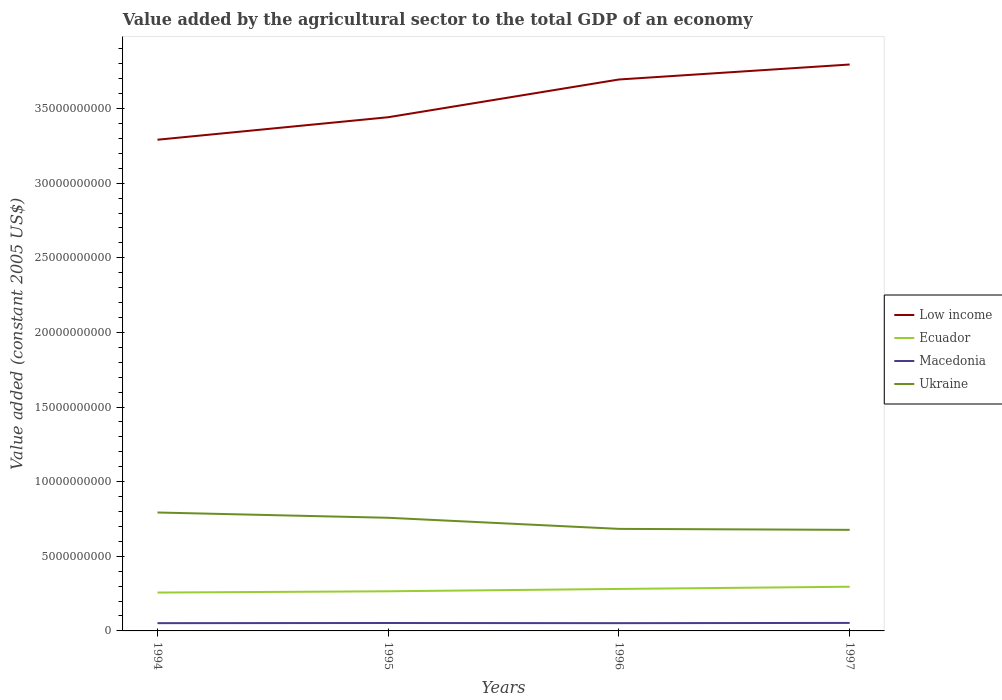Does the line corresponding to Ukraine intersect with the line corresponding to Low income?
Keep it short and to the point. No. Across all years, what is the maximum value added by the agricultural sector in Low income?
Ensure brevity in your answer.  3.29e+1. What is the total value added by the agricultural sector in Low income in the graph?
Ensure brevity in your answer.  -1.00e+09. What is the difference between the highest and the second highest value added by the agricultural sector in Low income?
Your answer should be very brief. 5.04e+09. Is the value added by the agricultural sector in Low income strictly greater than the value added by the agricultural sector in Macedonia over the years?
Offer a very short reply. No. How many lines are there?
Provide a short and direct response. 4. How many years are there in the graph?
Provide a short and direct response. 4. What is the title of the graph?
Your response must be concise. Value added by the agricultural sector to the total GDP of an economy. Does "Mongolia" appear as one of the legend labels in the graph?
Ensure brevity in your answer.  No. What is the label or title of the Y-axis?
Provide a short and direct response. Value added (constant 2005 US$). What is the Value added (constant 2005 US$) of Low income in 1994?
Your answer should be compact. 3.29e+1. What is the Value added (constant 2005 US$) of Ecuador in 1994?
Your response must be concise. 2.57e+09. What is the Value added (constant 2005 US$) of Macedonia in 1994?
Give a very brief answer. 5.20e+08. What is the Value added (constant 2005 US$) of Ukraine in 1994?
Ensure brevity in your answer.  7.94e+09. What is the Value added (constant 2005 US$) in Low income in 1995?
Provide a succinct answer. 3.44e+1. What is the Value added (constant 2005 US$) of Ecuador in 1995?
Offer a very short reply. 2.66e+09. What is the Value added (constant 2005 US$) in Macedonia in 1995?
Your response must be concise. 5.31e+08. What is the Value added (constant 2005 US$) in Ukraine in 1995?
Provide a succinct answer. 7.58e+09. What is the Value added (constant 2005 US$) of Low income in 1996?
Provide a short and direct response. 3.70e+1. What is the Value added (constant 2005 US$) of Ecuador in 1996?
Your answer should be compact. 2.81e+09. What is the Value added (constant 2005 US$) of Macedonia in 1996?
Provide a succinct answer. 5.20e+08. What is the Value added (constant 2005 US$) in Ukraine in 1996?
Keep it short and to the point. 6.84e+09. What is the Value added (constant 2005 US$) in Low income in 1997?
Your answer should be very brief. 3.80e+1. What is the Value added (constant 2005 US$) in Ecuador in 1997?
Make the answer very short. 2.96e+09. What is the Value added (constant 2005 US$) of Macedonia in 1997?
Your answer should be compact. 5.36e+08. What is the Value added (constant 2005 US$) of Ukraine in 1997?
Make the answer very short. 6.77e+09. Across all years, what is the maximum Value added (constant 2005 US$) in Low income?
Offer a terse response. 3.80e+1. Across all years, what is the maximum Value added (constant 2005 US$) of Ecuador?
Your answer should be compact. 2.96e+09. Across all years, what is the maximum Value added (constant 2005 US$) of Macedonia?
Ensure brevity in your answer.  5.36e+08. Across all years, what is the maximum Value added (constant 2005 US$) of Ukraine?
Your answer should be very brief. 7.94e+09. Across all years, what is the minimum Value added (constant 2005 US$) in Low income?
Your response must be concise. 3.29e+1. Across all years, what is the minimum Value added (constant 2005 US$) of Ecuador?
Provide a succinct answer. 2.57e+09. Across all years, what is the minimum Value added (constant 2005 US$) of Macedonia?
Your response must be concise. 5.20e+08. Across all years, what is the minimum Value added (constant 2005 US$) of Ukraine?
Offer a terse response. 6.77e+09. What is the total Value added (constant 2005 US$) in Low income in the graph?
Your answer should be compact. 1.42e+11. What is the total Value added (constant 2005 US$) of Ecuador in the graph?
Your answer should be very brief. 1.10e+1. What is the total Value added (constant 2005 US$) in Macedonia in the graph?
Ensure brevity in your answer.  2.11e+09. What is the total Value added (constant 2005 US$) of Ukraine in the graph?
Ensure brevity in your answer.  2.91e+1. What is the difference between the Value added (constant 2005 US$) of Low income in 1994 and that in 1995?
Make the answer very short. -1.51e+09. What is the difference between the Value added (constant 2005 US$) of Ecuador in 1994 and that in 1995?
Ensure brevity in your answer.  -8.60e+07. What is the difference between the Value added (constant 2005 US$) in Macedonia in 1994 and that in 1995?
Ensure brevity in your answer.  -1.08e+07. What is the difference between the Value added (constant 2005 US$) in Ukraine in 1994 and that in 1995?
Your response must be concise. 3.53e+08. What is the difference between the Value added (constant 2005 US$) of Low income in 1994 and that in 1996?
Provide a succinct answer. -4.04e+09. What is the difference between the Value added (constant 2005 US$) of Ecuador in 1994 and that in 1996?
Keep it short and to the point. -2.43e+08. What is the difference between the Value added (constant 2005 US$) in Macedonia in 1994 and that in 1996?
Give a very brief answer. 8.42e+04. What is the difference between the Value added (constant 2005 US$) in Ukraine in 1994 and that in 1996?
Offer a very short reply. 1.10e+09. What is the difference between the Value added (constant 2005 US$) of Low income in 1994 and that in 1997?
Your answer should be very brief. -5.04e+09. What is the difference between the Value added (constant 2005 US$) in Ecuador in 1994 and that in 1997?
Your answer should be compact. -3.90e+08. What is the difference between the Value added (constant 2005 US$) of Macedonia in 1994 and that in 1997?
Keep it short and to the point. -1.57e+07. What is the difference between the Value added (constant 2005 US$) of Ukraine in 1994 and that in 1997?
Offer a very short reply. 1.16e+09. What is the difference between the Value added (constant 2005 US$) in Low income in 1995 and that in 1996?
Keep it short and to the point. -2.53e+09. What is the difference between the Value added (constant 2005 US$) of Ecuador in 1995 and that in 1996?
Provide a short and direct response. -1.57e+08. What is the difference between the Value added (constant 2005 US$) of Macedonia in 1995 and that in 1996?
Offer a very short reply. 1.09e+07. What is the difference between the Value added (constant 2005 US$) of Ukraine in 1995 and that in 1996?
Ensure brevity in your answer.  7.44e+08. What is the difference between the Value added (constant 2005 US$) in Low income in 1995 and that in 1997?
Offer a terse response. -3.53e+09. What is the difference between the Value added (constant 2005 US$) of Ecuador in 1995 and that in 1997?
Keep it short and to the point. -3.04e+08. What is the difference between the Value added (constant 2005 US$) in Macedonia in 1995 and that in 1997?
Your answer should be very brief. -4.85e+06. What is the difference between the Value added (constant 2005 US$) in Ukraine in 1995 and that in 1997?
Your answer should be compact. 8.09e+08. What is the difference between the Value added (constant 2005 US$) of Low income in 1996 and that in 1997?
Your answer should be very brief. -1.00e+09. What is the difference between the Value added (constant 2005 US$) of Ecuador in 1996 and that in 1997?
Offer a very short reply. -1.47e+08. What is the difference between the Value added (constant 2005 US$) of Macedonia in 1996 and that in 1997?
Make the answer very short. -1.57e+07. What is the difference between the Value added (constant 2005 US$) in Ukraine in 1996 and that in 1997?
Offer a very short reply. 6.52e+07. What is the difference between the Value added (constant 2005 US$) of Low income in 1994 and the Value added (constant 2005 US$) of Ecuador in 1995?
Offer a terse response. 3.03e+1. What is the difference between the Value added (constant 2005 US$) of Low income in 1994 and the Value added (constant 2005 US$) of Macedonia in 1995?
Provide a succinct answer. 3.24e+1. What is the difference between the Value added (constant 2005 US$) in Low income in 1994 and the Value added (constant 2005 US$) in Ukraine in 1995?
Ensure brevity in your answer.  2.53e+1. What is the difference between the Value added (constant 2005 US$) in Ecuador in 1994 and the Value added (constant 2005 US$) in Macedonia in 1995?
Offer a terse response. 2.04e+09. What is the difference between the Value added (constant 2005 US$) of Ecuador in 1994 and the Value added (constant 2005 US$) of Ukraine in 1995?
Provide a succinct answer. -5.01e+09. What is the difference between the Value added (constant 2005 US$) in Macedonia in 1994 and the Value added (constant 2005 US$) in Ukraine in 1995?
Your response must be concise. -7.06e+09. What is the difference between the Value added (constant 2005 US$) in Low income in 1994 and the Value added (constant 2005 US$) in Ecuador in 1996?
Provide a short and direct response. 3.01e+1. What is the difference between the Value added (constant 2005 US$) of Low income in 1994 and the Value added (constant 2005 US$) of Macedonia in 1996?
Offer a very short reply. 3.24e+1. What is the difference between the Value added (constant 2005 US$) of Low income in 1994 and the Value added (constant 2005 US$) of Ukraine in 1996?
Offer a very short reply. 2.61e+1. What is the difference between the Value added (constant 2005 US$) in Ecuador in 1994 and the Value added (constant 2005 US$) in Macedonia in 1996?
Offer a terse response. 2.05e+09. What is the difference between the Value added (constant 2005 US$) in Ecuador in 1994 and the Value added (constant 2005 US$) in Ukraine in 1996?
Provide a succinct answer. -4.27e+09. What is the difference between the Value added (constant 2005 US$) of Macedonia in 1994 and the Value added (constant 2005 US$) of Ukraine in 1996?
Your answer should be compact. -6.32e+09. What is the difference between the Value added (constant 2005 US$) of Low income in 1994 and the Value added (constant 2005 US$) of Ecuador in 1997?
Offer a terse response. 3.00e+1. What is the difference between the Value added (constant 2005 US$) of Low income in 1994 and the Value added (constant 2005 US$) of Macedonia in 1997?
Offer a terse response. 3.24e+1. What is the difference between the Value added (constant 2005 US$) in Low income in 1994 and the Value added (constant 2005 US$) in Ukraine in 1997?
Make the answer very short. 2.61e+1. What is the difference between the Value added (constant 2005 US$) of Ecuador in 1994 and the Value added (constant 2005 US$) of Macedonia in 1997?
Offer a terse response. 2.03e+09. What is the difference between the Value added (constant 2005 US$) in Ecuador in 1994 and the Value added (constant 2005 US$) in Ukraine in 1997?
Your answer should be very brief. -4.20e+09. What is the difference between the Value added (constant 2005 US$) in Macedonia in 1994 and the Value added (constant 2005 US$) in Ukraine in 1997?
Provide a short and direct response. -6.25e+09. What is the difference between the Value added (constant 2005 US$) in Low income in 1995 and the Value added (constant 2005 US$) in Ecuador in 1996?
Provide a short and direct response. 3.16e+1. What is the difference between the Value added (constant 2005 US$) in Low income in 1995 and the Value added (constant 2005 US$) in Macedonia in 1996?
Ensure brevity in your answer.  3.39e+1. What is the difference between the Value added (constant 2005 US$) of Low income in 1995 and the Value added (constant 2005 US$) of Ukraine in 1996?
Keep it short and to the point. 2.76e+1. What is the difference between the Value added (constant 2005 US$) in Ecuador in 1995 and the Value added (constant 2005 US$) in Macedonia in 1996?
Your answer should be very brief. 2.14e+09. What is the difference between the Value added (constant 2005 US$) of Ecuador in 1995 and the Value added (constant 2005 US$) of Ukraine in 1996?
Keep it short and to the point. -4.18e+09. What is the difference between the Value added (constant 2005 US$) of Macedonia in 1995 and the Value added (constant 2005 US$) of Ukraine in 1996?
Your answer should be very brief. -6.31e+09. What is the difference between the Value added (constant 2005 US$) of Low income in 1995 and the Value added (constant 2005 US$) of Ecuador in 1997?
Give a very brief answer. 3.15e+1. What is the difference between the Value added (constant 2005 US$) in Low income in 1995 and the Value added (constant 2005 US$) in Macedonia in 1997?
Keep it short and to the point. 3.39e+1. What is the difference between the Value added (constant 2005 US$) of Low income in 1995 and the Value added (constant 2005 US$) of Ukraine in 1997?
Give a very brief answer. 2.76e+1. What is the difference between the Value added (constant 2005 US$) in Ecuador in 1995 and the Value added (constant 2005 US$) in Macedonia in 1997?
Offer a very short reply. 2.12e+09. What is the difference between the Value added (constant 2005 US$) of Ecuador in 1995 and the Value added (constant 2005 US$) of Ukraine in 1997?
Make the answer very short. -4.12e+09. What is the difference between the Value added (constant 2005 US$) of Macedonia in 1995 and the Value added (constant 2005 US$) of Ukraine in 1997?
Your response must be concise. -6.24e+09. What is the difference between the Value added (constant 2005 US$) in Low income in 1996 and the Value added (constant 2005 US$) in Ecuador in 1997?
Your response must be concise. 3.40e+1. What is the difference between the Value added (constant 2005 US$) of Low income in 1996 and the Value added (constant 2005 US$) of Macedonia in 1997?
Give a very brief answer. 3.64e+1. What is the difference between the Value added (constant 2005 US$) in Low income in 1996 and the Value added (constant 2005 US$) in Ukraine in 1997?
Your answer should be compact. 3.02e+1. What is the difference between the Value added (constant 2005 US$) of Ecuador in 1996 and the Value added (constant 2005 US$) of Macedonia in 1997?
Provide a succinct answer. 2.28e+09. What is the difference between the Value added (constant 2005 US$) in Ecuador in 1996 and the Value added (constant 2005 US$) in Ukraine in 1997?
Provide a short and direct response. -3.96e+09. What is the difference between the Value added (constant 2005 US$) in Macedonia in 1996 and the Value added (constant 2005 US$) in Ukraine in 1997?
Keep it short and to the point. -6.25e+09. What is the average Value added (constant 2005 US$) in Low income per year?
Give a very brief answer. 3.56e+1. What is the average Value added (constant 2005 US$) in Ecuador per year?
Your answer should be compact. 2.75e+09. What is the average Value added (constant 2005 US$) in Macedonia per year?
Your answer should be compact. 5.27e+08. What is the average Value added (constant 2005 US$) of Ukraine per year?
Provide a short and direct response. 7.28e+09. In the year 1994, what is the difference between the Value added (constant 2005 US$) in Low income and Value added (constant 2005 US$) in Ecuador?
Offer a very short reply. 3.03e+1. In the year 1994, what is the difference between the Value added (constant 2005 US$) of Low income and Value added (constant 2005 US$) of Macedonia?
Keep it short and to the point. 3.24e+1. In the year 1994, what is the difference between the Value added (constant 2005 US$) of Low income and Value added (constant 2005 US$) of Ukraine?
Provide a short and direct response. 2.50e+1. In the year 1994, what is the difference between the Value added (constant 2005 US$) in Ecuador and Value added (constant 2005 US$) in Macedonia?
Provide a short and direct response. 2.05e+09. In the year 1994, what is the difference between the Value added (constant 2005 US$) of Ecuador and Value added (constant 2005 US$) of Ukraine?
Ensure brevity in your answer.  -5.36e+09. In the year 1994, what is the difference between the Value added (constant 2005 US$) of Macedonia and Value added (constant 2005 US$) of Ukraine?
Offer a terse response. -7.42e+09. In the year 1995, what is the difference between the Value added (constant 2005 US$) of Low income and Value added (constant 2005 US$) of Ecuador?
Your response must be concise. 3.18e+1. In the year 1995, what is the difference between the Value added (constant 2005 US$) of Low income and Value added (constant 2005 US$) of Macedonia?
Offer a very short reply. 3.39e+1. In the year 1995, what is the difference between the Value added (constant 2005 US$) of Low income and Value added (constant 2005 US$) of Ukraine?
Your answer should be very brief. 2.68e+1. In the year 1995, what is the difference between the Value added (constant 2005 US$) in Ecuador and Value added (constant 2005 US$) in Macedonia?
Your answer should be compact. 2.13e+09. In the year 1995, what is the difference between the Value added (constant 2005 US$) of Ecuador and Value added (constant 2005 US$) of Ukraine?
Your response must be concise. -4.93e+09. In the year 1995, what is the difference between the Value added (constant 2005 US$) in Macedonia and Value added (constant 2005 US$) in Ukraine?
Provide a succinct answer. -7.05e+09. In the year 1996, what is the difference between the Value added (constant 2005 US$) of Low income and Value added (constant 2005 US$) of Ecuador?
Provide a succinct answer. 3.41e+1. In the year 1996, what is the difference between the Value added (constant 2005 US$) in Low income and Value added (constant 2005 US$) in Macedonia?
Ensure brevity in your answer.  3.64e+1. In the year 1996, what is the difference between the Value added (constant 2005 US$) of Low income and Value added (constant 2005 US$) of Ukraine?
Your answer should be very brief. 3.01e+1. In the year 1996, what is the difference between the Value added (constant 2005 US$) in Ecuador and Value added (constant 2005 US$) in Macedonia?
Your answer should be compact. 2.29e+09. In the year 1996, what is the difference between the Value added (constant 2005 US$) of Ecuador and Value added (constant 2005 US$) of Ukraine?
Your response must be concise. -4.02e+09. In the year 1996, what is the difference between the Value added (constant 2005 US$) in Macedonia and Value added (constant 2005 US$) in Ukraine?
Make the answer very short. -6.32e+09. In the year 1997, what is the difference between the Value added (constant 2005 US$) of Low income and Value added (constant 2005 US$) of Ecuador?
Offer a terse response. 3.50e+1. In the year 1997, what is the difference between the Value added (constant 2005 US$) of Low income and Value added (constant 2005 US$) of Macedonia?
Offer a terse response. 3.74e+1. In the year 1997, what is the difference between the Value added (constant 2005 US$) of Low income and Value added (constant 2005 US$) of Ukraine?
Provide a succinct answer. 3.12e+1. In the year 1997, what is the difference between the Value added (constant 2005 US$) in Ecuador and Value added (constant 2005 US$) in Macedonia?
Provide a short and direct response. 2.42e+09. In the year 1997, what is the difference between the Value added (constant 2005 US$) in Ecuador and Value added (constant 2005 US$) in Ukraine?
Provide a succinct answer. -3.81e+09. In the year 1997, what is the difference between the Value added (constant 2005 US$) in Macedonia and Value added (constant 2005 US$) in Ukraine?
Offer a very short reply. -6.24e+09. What is the ratio of the Value added (constant 2005 US$) in Low income in 1994 to that in 1995?
Offer a terse response. 0.96. What is the ratio of the Value added (constant 2005 US$) of Ecuador in 1994 to that in 1995?
Make the answer very short. 0.97. What is the ratio of the Value added (constant 2005 US$) of Macedonia in 1994 to that in 1995?
Your answer should be compact. 0.98. What is the ratio of the Value added (constant 2005 US$) of Ukraine in 1994 to that in 1995?
Ensure brevity in your answer.  1.05. What is the ratio of the Value added (constant 2005 US$) of Low income in 1994 to that in 1996?
Offer a very short reply. 0.89. What is the ratio of the Value added (constant 2005 US$) of Ecuador in 1994 to that in 1996?
Your response must be concise. 0.91. What is the ratio of the Value added (constant 2005 US$) in Macedonia in 1994 to that in 1996?
Ensure brevity in your answer.  1. What is the ratio of the Value added (constant 2005 US$) of Ukraine in 1994 to that in 1996?
Offer a terse response. 1.16. What is the ratio of the Value added (constant 2005 US$) of Low income in 1994 to that in 1997?
Offer a terse response. 0.87. What is the ratio of the Value added (constant 2005 US$) of Ecuador in 1994 to that in 1997?
Give a very brief answer. 0.87. What is the ratio of the Value added (constant 2005 US$) in Macedonia in 1994 to that in 1997?
Give a very brief answer. 0.97. What is the ratio of the Value added (constant 2005 US$) in Ukraine in 1994 to that in 1997?
Make the answer very short. 1.17. What is the ratio of the Value added (constant 2005 US$) in Low income in 1995 to that in 1996?
Keep it short and to the point. 0.93. What is the ratio of the Value added (constant 2005 US$) of Ecuador in 1995 to that in 1996?
Keep it short and to the point. 0.94. What is the ratio of the Value added (constant 2005 US$) in Macedonia in 1995 to that in 1996?
Offer a very short reply. 1.02. What is the ratio of the Value added (constant 2005 US$) of Ukraine in 1995 to that in 1996?
Ensure brevity in your answer.  1.11. What is the ratio of the Value added (constant 2005 US$) of Low income in 1995 to that in 1997?
Offer a terse response. 0.91. What is the ratio of the Value added (constant 2005 US$) in Ecuador in 1995 to that in 1997?
Make the answer very short. 0.9. What is the ratio of the Value added (constant 2005 US$) in Macedonia in 1995 to that in 1997?
Ensure brevity in your answer.  0.99. What is the ratio of the Value added (constant 2005 US$) in Ukraine in 1995 to that in 1997?
Offer a very short reply. 1.12. What is the ratio of the Value added (constant 2005 US$) in Low income in 1996 to that in 1997?
Your answer should be compact. 0.97. What is the ratio of the Value added (constant 2005 US$) in Ecuador in 1996 to that in 1997?
Your answer should be very brief. 0.95. What is the ratio of the Value added (constant 2005 US$) in Macedonia in 1996 to that in 1997?
Your answer should be very brief. 0.97. What is the ratio of the Value added (constant 2005 US$) in Ukraine in 1996 to that in 1997?
Provide a short and direct response. 1.01. What is the difference between the highest and the second highest Value added (constant 2005 US$) in Low income?
Provide a succinct answer. 1.00e+09. What is the difference between the highest and the second highest Value added (constant 2005 US$) of Ecuador?
Keep it short and to the point. 1.47e+08. What is the difference between the highest and the second highest Value added (constant 2005 US$) of Macedonia?
Provide a succinct answer. 4.85e+06. What is the difference between the highest and the second highest Value added (constant 2005 US$) in Ukraine?
Keep it short and to the point. 3.53e+08. What is the difference between the highest and the lowest Value added (constant 2005 US$) of Low income?
Keep it short and to the point. 5.04e+09. What is the difference between the highest and the lowest Value added (constant 2005 US$) in Ecuador?
Provide a succinct answer. 3.90e+08. What is the difference between the highest and the lowest Value added (constant 2005 US$) in Macedonia?
Your response must be concise. 1.57e+07. What is the difference between the highest and the lowest Value added (constant 2005 US$) in Ukraine?
Your answer should be compact. 1.16e+09. 